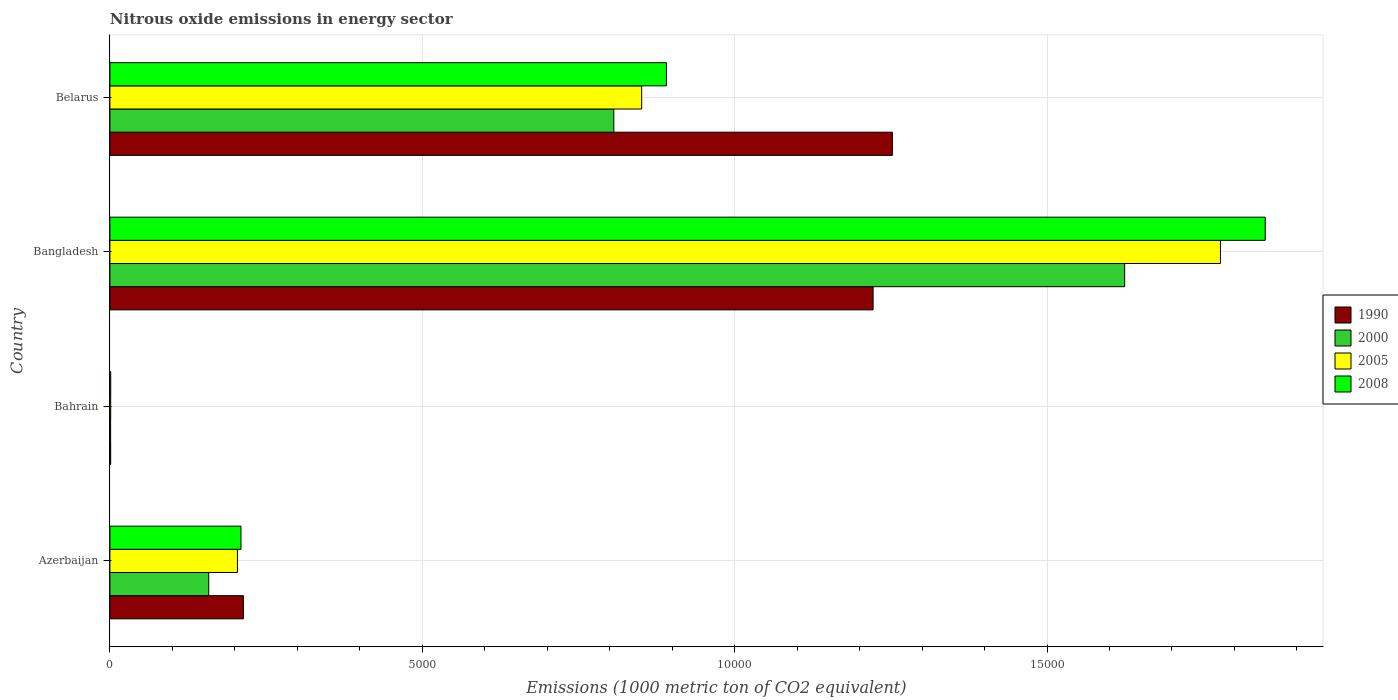How many different coloured bars are there?
Offer a terse response. 4. How many groups of bars are there?
Your response must be concise. 4. Are the number of bars per tick equal to the number of legend labels?
Provide a short and direct response. Yes. How many bars are there on the 2nd tick from the top?
Your response must be concise. 4. How many bars are there on the 2nd tick from the bottom?
Provide a succinct answer. 4. What is the label of the 3rd group of bars from the top?
Your answer should be compact. Bahrain. In how many cases, is the number of bars for a given country not equal to the number of legend labels?
Ensure brevity in your answer.  0. What is the amount of nitrous oxide emitted in 2008 in Belarus?
Offer a very short reply. 8908.4. Across all countries, what is the maximum amount of nitrous oxide emitted in 1990?
Offer a terse response. 1.25e+04. In which country was the amount of nitrous oxide emitted in 2005 minimum?
Your response must be concise. Bahrain. What is the total amount of nitrous oxide emitted in 1990 in the graph?
Offer a terse response. 2.69e+04. What is the difference between the amount of nitrous oxide emitted in 2005 in Bahrain and that in Bangladesh?
Give a very brief answer. -1.78e+04. What is the difference between the amount of nitrous oxide emitted in 2005 in Bahrain and the amount of nitrous oxide emitted in 2000 in Azerbaijan?
Your answer should be compact. -1569. What is the average amount of nitrous oxide emitted in 2000 per country?
Your answer should be compact. 6475.62. What is the difference between the amount of nitrous oxide emitted in 1990 and amount of nitrous oxide emitted in 2005 in Azerbaijan?
Your answer should be very brief. 95.6. In how many countries, is the amount of nitrous oxide emitted in 2000 greater than 4000 1000 metric ton?
Your response must be concise. 2. What is the ratio of the amount of nitrous oxide emitted in 1990 in Azerbaijan to that in Belarus?
Give a very brief answer. 0.17. Is the amount of nitrous oxide emitted in 2005 in Azerbaijan less than that in Bahrain?
Ensure brevity in your answer.  No. What is the difference between the highest and the second highest amount of nitrous oxide emitted in 1990?
Offer a very short reply. 308.3. What is the difference between the highest and the lowest amount of nitrous oxide emitted in 2005?
Your answer should be very brief. 1.78e+04. In how many countries, is the amount of nitrous oxide emitted in 1990 greater than the average amount of nitrous oxide emitted in 1990 taken over all countries?
Give a very brief answer. 2. Is the sum of the amount of nitrous oxide emitted in 2005 in Bahrain and Bangladesh greater than the maximum amount of nitrous oxide emitted in 1990 across all countries?
Provide a succinct answer. Yes. Is it the case that in every country, the sum of the amount of nitrous oxide emitted in 2000 and amount of nitrous oxide emitted in 2008 is greater than the sum of amount of nitrous oxide emitted in 2005 and amount of nitrous oxide emitted in 1990?
Give a very brief answer. No. What does the 3rd bar from the top in Belarus represents?
Your response must be concise. 2000. What does the 2nd bar from the bottom in Belarus represents?
Your response must be concise. 2000. Are all the bars in the graph horizontal?
Make the answer very short. Yes. What is the difference between two consecutive major ticks on the X-axis?
Provide a succinct answer. 5000. Does the graph contain grids?
Make the answer very short. Yes. Where does the legend appear in the graph?
Your answer should be compact. Center right. How many legend labels are there?
Your response must be concise. 4. How are the legend labels stacked?
Make the answer very short. Vertical. What is the title of the graph?
Give a very brief answer. Nitrous oxide emissions in energy sector. What is the label or title of the X-axis?
Offer a terse response. Emissions (1000 metric ton of CO2 equivalent). What is the label or title of the Y-axis?
Make the answer very short. Country. What is the Emissions (1000 metric ton of CO2 equivalent) in 1990 in Azerbaijan?
Ensure brevity in your answer.  2137.1. What is the Emissions (1000 metric ton of CO2 equivalent) of 2000 in Azerbaijan?
Keep it short and to the point. 1582.1. What is the Emissions (1000 metric ton of CO2 equivalent) of 2005 in Azerbaijan?
Offer a terse response. 2041.5. What is the Emissions (1000 metric ton of CO2 equivalent) in 2008 in Azerbaijan?
Provide a short and direct response. 2098. What is the Emissions (1000 metric ton of CO2 equivalent) in 2005 in Bahrain?
Provide a succinct answer. 13.1. What is the Emissions (1000 metric ton of CO2 equivalent) of 2008 in Bahrain?
Offer a very short reply. 13.6. What is the Emissions (1000 metric ton of CO2 equivalent) of 1990 in Bangladesh?
Keep it short and to the point. 1.22e+04. What is the Emissions (1000 metric ton of CO2 equivalent) in 2000 in Bangladesh?
Your answer should be very brief. 1.62e+04. What is the Emissions (1000 metric ton of CO2 equivalent) in 2005 in Bangladesh?
Ensure brevity in your answer.  1.78e+04. What is the Emissions (1000 metric ton of CO2 equivalent) in 2008 in Bangladesh?
Ensure brevity in your answer.  1.85e+04. What is the Emissions (1000 metric ton of CO2 equivalent) in 1990 in Belarus?
Provide a succinct answer. 1.25e+04. What is the Emissions (1000 metric ton of CO2 equivalent) in 2000 in Belarus?
Ensure brevity in your answer.  8066.2. What is the Emissions (1000 metric ton of CO2 equivalent) in 2005 in Belarus?
Give a very brief answer. 8511.9. What is the Emissions (1000 metric ton of CO2 equivalent) in 2008 in Belarus?
Offer a very short reply. 8908.4. Across all countries, what is the maximum Emissions (1000 metric ton of CO2 equivalent) of 1990?
Provide a short and direct response. 1.25e+04. Across all countries, what is the maximum Emissions (1000 metric ton of CO2 equivalent) of 2000?
Provide a short and direct response. 1.62e+04. Across all countries, what is the maximum Emissions (1000 metric ton of CO2 equivalent) of 2005?
Your answer should be compact. 1.78e+04. Across all countries, what is the maximum Emissions (1000 metric ton of CO2 equivalent) of 2008?
Ensure brevity in your answer.  1.85e+04. Across all countries, what is the minimum Emissions (1000 metric ton of CO2 equivalent) in 2000?
Your response must be concise. 11.8. Across all countries, what is the minimum Emissions (1000 metric ton of CO2 equivalent) of 2005?
Provide a short and direct response. 13.1. What is the total Emissions (1000 metric ton of CO2 equivalent) in 1990 in the graph?
Keep it short and to the point. 2.69e+04. What is the total Emissions (1000 metric ton of CO2 equivalent) of 2000 in the graph?
Offer a very short reply. 2.59e+04. What is the total Emissions (1000 metric ton of CO2 equivalent) in 2005 in the graph?
Give a very brief answer. 2.83e+04. What is the total Emissions (1000 metric ton of CO2 equivalent) of 2008 in the graph?
Your answer should be compact. 2.95e+04. What is the difference between the Emissions (1000 metric ton of CO2 equivalent) of 1990 in Azerbaijan and that in Bahrain?
Your response must be concise. 2124.6. What is the difference between the Emissions (1000 metric ton of CO2 equivalent) of 2000 in Azerbaijan and that in Bahrain?
Provide a short and direct response. 1570.3. What is the difference between the Emissions (1000 metric ton of CO2 equivalent) in 2005 in Azerbaijan and that in Bahrain?
Offer a very short reply. 2028.4. What is the difference between the Emissions (1000 metric ton of CO2 equivalent) of 2008 in Azerbaijan and that in Bahrain?
Your response must be concise. 2084.4. What is the difference between the Emissions (1000 metric ton of CO2 equivalent) of 1990 in Azerbaijan and that in Bangladesh?
Keep it short and to the point. -1.01e+04. What is the difference between the Emissions (1000 metric ton of CO2 equivalent) of 2000 in Azerbaijan and that in Bangladesh?
Provide a short and direct response. -1.47e+04. What is the difference between the Emissions (1000 metric ton of CO2 equivalent) in 2005 in Azerbaijan and that in Bangladesh?
Provide a succinct answer. -1.57e+04. What is the difference between the Emissions (1000 metric ton of CO2 equivalent) in 2008 in Azerbaijan and that in Bangladesh?
Your response must be concise. -1.64e+04. What is the difference between the Emissions (1000 metric ton of CO2 equivalent) in 1990 in Azerbaijan and that in Belarus?
Provide a short and direct response. -1.04e+04. What is the difference between the Emissions (1000 metric ton of CO2 equivalent) of 2000 in Azerbaijan and that in Belarus?
Offer a terse response. -6484.1. What is the difference between the Emissions (1000 metric ton of CO2 equivalent) of 2005 in Azerbaijan and that in Belarus?
Ensure brevity in your answer.  -6470.4. What is the difference between the Emissions (1000 metric ton of CO2 equivalent) in 2008 in Azerbaijan and that in Belarus?
Keep it short and to the point. -6810.4. What is the difference between the Emissions (1000 metric ton of CO2 equivalent) of 1990 in Bahrain and that in Bangladesh?
Ensure brevity in your answer.  -1.22e+04. What is the difference between the Emissions (1000 metric ton of CO2 equivalent) of 2000 in Bahrain and that in Bangladesh?
Your answer should be very brief. -1.62e+04. What is the difference between the Emissions (1000 metric ton of CO2 equivalent) in 2005 in Bahrain and that in Bangladesh?
Your response must be concise. -1.78e+04. What is the difference between the Emissions (1000 metric ton of CO2 equivalent) of 2008 in Bahrain and that in Bangladesh?
Offer a terse response. -1.85e+04. What is the difference between the Emissions (1000 metric ton of CO2 equivalent) of 1990 in Bahrain and that in Belarus?
Offer a very short reply. -1.25e+04. What is the difference between the Emissions (1000 metric ton of CO2 equivalent) of 2000 in Bahrain and that in Belarus?
Offer a terse response. -8054.4. What is the difference between the Emissions (1000 metric ton of CO2 equivalent) of 2005 in Bahrain and that in Belarus?
Make the answer very short. -8498.8. What is the difference between the Emissions (1000 metric ton of CO2 equivalent) of 2008 in Bahrain and that in Belarus?
Offer a very short reply. -8894.8. What is the difference between the Emissions (1000 metric ton of CO2 equivalent) in 1990 in Bangladesh and that in Belarus?
Give a very brief answer. -308.3. What is the difference between the Emissions (1000 metric ton of CO2 equivalent) in 2000 in Bangladesh and that in Belarus?
Make the answer very short. 8176.2. What is the difference between the Emissions (1000 metric ton of CO2 equivalent) in 2005 in Bangladesh and that in Belarus?
Offer a very short reply. 9263.9. What is the difference between the Emissions (1000 metric ton of CO2 equivalent) in 2008 in Bangladesh and that in Belarus?
Ensure brevity in your answer.  9584.1. What is the difference between the Emissions (1000 metric ton of CO2 equivalent) of 1990 in Azerbaijan and the Emissions (1000 metric ton of CO2 equivalent) of 2000 in Bahrain?
Make the answer very short. 2125.3. What is the difference between the Emissions (1000 metric ton of CO2 equivalent) in 1990 in Azerbaijan and the Emissions (1000 metric ton of CO2 equivalent) in 2005 in Bahrain?
Provide a succinct answer. 2124. What is the difference between the Emissions (1000 metric ton of CO2 equivalent) in 1990 in Azerbaijan and the Emissions (1000 metric ton of CO2 equivalent) in 2008 in Bahrain?
Your answer should be very brief. 2123.5. What is the difference between the Emissions (1000 metric ton of CO2 equivalent) in 2000 in Azerbaijan and the Emissions (1000 metric ton of CO2 equivalent) in 2005 in Bahrain?
Make the answer very short. 1569. What is the difference between the Emissions (1000 metric ton of CO2 equivalent) in 2000 in Azerbaijan and the Emissions (1000 metric ton of CO2 equivalent) in 2008 in Bahrain?
Ensure brevity in your answer.  1568.5. What is the difference between the Emissions (1000 metric ton of CO2 equivalent) in 2005 in Azerbaijan and the Emissions (1000 metric ton of CO2 equivalent) in 2008 in Bahrain?
Make the answer very short. 2027.9. What is the difference between the Emissions (1000 metric ton of CO2 equivalent) of 1990 in Azerbaijan and the Emissions (1000 metric ton of CO2 equivalent) of 2000 in Bangladesh?
Your answer should be very brief. -1.41e+04. What is the difference between the Emissions (1000 metric ton of CO2 equivalent) in 1990 in Azerbaijan and the Emissions (1000 metric ton of CO2 equivalent) in 2005 in Bangladesh?
Ensure brevity in your answer.  -1.56e+04. What is the difference between the Emissions (1000 metric ton of CO2 equivalent) in 1990 in Azerbaijan and the Emissions (1000 metric ton of CO2 equivalent) in 2008 in Bangladesh?
Provide a succinct answer. -1.64e+04. What is the difference between the Emissions (1000 metric ton of CO2 equivalent) in 2000 in Azerbaijan and the Emissions (1000 metric ton of CO2 equivalent) in 2005 in Bangladesh?
Your response must be concise. -1.62e+04. What is the difference between the Emissions (1000 metric ton of CO2 equivalent) in 2000 in Azerbaijan and the Emissions (1000 metric ton of CO2 equivalent) in 2008 in Bangladesh?
Provide a short and direct response. -1.69e+04. What is the difference between the Emissions (1000 metric ton of CO2 equivalent) of 2005 in Azerbaijan and the Emissions (1000 metric ton of CO2 equivalent) of 2008 in Bangladesh?
Your answer should be compact. -1.65e+04. What is the difference between the Emissions (1000 metric ton of CO2 equivalent) of 1990 in Azerbaijan and the Emissions (1000 metric ton of CO2 equivalent) of 2000 in Belarus?
Provide a short and direct response. -5929.1. What is the difference between the Emissions (1000 metric ton of CO2 equivalent) of 1990 in Azerbaijan and the Emissions (1000 metric ton of CO2 equivalent) of 2005 in Belarus?
Provide a succinct answer. -6374.8. What is the difference between the Emissions (1000 metric ton of CO2 equivalent) of 1990 in Azerbaijan and the Emissions (1000 metric ton of CO2 equivalent) of 2008 in Belarus?
Offer a terse response. -6771.3. What is the difference between the Emissions (1000 metric ton of CO2 equivalent) in 2000 in Azerbaijan and the Emissions (1000 metric ton of CO2 equivalent) in 2005 in Belarus?
Provide a succinct answer. -6929.8. What is the difference between the Emissions (1000 metric ton of CO2 equivalent) in 2000 in Azerbaijan and the Emissions (1000 metric ton of CO2 equivalent) in 2008 in Belarus?
Your answer should be compact. -7326.3. What is the difference between the Emissions (1000 metric ton of CO2 equivalent) in 2005 in Azerbaijan and the Emissions (1000 metric ton of CO2 equivalent) in 2008 in Belarus?
Offer a very short reply. -6866.9. What is the difference between the Emissions (1000 metric ton of CO2 equivalent) in 1990 in Bahrain and the Emissions (1000 metric ton of CO2 equivalent) in 2000 in Bangladesh?
Give a very brief answer. -1.62e+04. What is the difference between the Emissions (1000 metric ton of CO2 equivalent) of 1990 in Bahrain and the Emissions (1000 metric ton of CO2 equivalent) of 2005 in Bangladesh?
Make the answer very short. -1.78e+04. What is the difference between the Emissions (1000 metric ton of CO2 equivalent) of 1990 in Bahrain and the Emissions (1000 metric ton of CO2 equivalent) of 2008 in Bangladesh?
Keep it short and to the point. -1.85e+04. What is the difference between the Emissions (1000 metric ton of CO2 equivalent) in 2000 in Bahrain and the Emissions (1000 metric ton of CO2 equivalent) in 2005 in Bangladesh?
Offer a very short reply. -1.78e+04. What is the difference between the Emissions (1000 metric ton of CO2 equivalent) of 2000 in Bahrain and the Emissions (1000 metric ton of CO2 equivalent) of 2008 in Bangladesh?
Your answer should be very brief. -1.85e+04. What is the difference between the Emissions (1000 metric ton of CO2 equivalent) in 2005 in Bahrain and the Emissions (1000 metric ton of CO2 equivalent) in 2008 in Bangladesh?
Your answer should be very brief. -1.85e+04. What is the difference between the Emissions (1000 metric ton of CO2 equivalent) in 1990 in Bahrain and the Emissions (1000 metric ton of CO2 equivalent) in 2000 in Belarus?
Keep it short and to the point. -8053.7. What is the difference between the Emissions (1000 metric ton of CO2 equivalent) in 1990 in Bahrain and the Emissions (1000 metric ton of CO2 equivalent) in 2005 in Belarus?
Give a very brief answer. -8499.4. What is the difference between the Emissions (1000 metric ton of CO2 equivalent) in 1990 in Bahrain and the Emissions (1000 metric ton of CO2 equivalent) in 2008 in Belarus?
Provide a short and direct response. -8895.9. What is the difference between the Emissions (1000 metric ton of CO2 equivalent) in 2000 in Bahrain and the Emissions (1000 metric ton of CO2 equivalent) in 2005 in Belarus?
Your answer should be compact. -8500.1. What is the difference between the Emissions (1000 metric ton of CO2 equivalent) in 2000 in Bahrain and the Emissions (1000 metric ton of CO2 equivalent) in 2008 in Belarus?
Your answer should be compact. -8896.6. What is the difference between the Emissions (1000 metric ton of CO2 equivalent) of 2005 in Bahrain and the Emissions (1000 metric ton of CO2 equivalent) of 2008 in Belarus?
Offer a very short reply. -8895.3. What is the difference between the Emissions (1000 metric ton of CO2 equivalent) of 1990 in Bangladesh and the Emissions (1000 metric ton of CO2 equivalent) of 2000 in Belarus?
Give a very brief answer. 4150.1. What is the difference between the Emissions (1000 metric ton of CO2 equivalent) of 1990 in Bangladesh and the Emissions (1000 metric ton of CO2 equivalent) of 2005 in Belarus?
Your answer should be very brief. 3704.4. What is the difference between the Emissions (1000 metric ton of CO2 equivalent) of 1990 in Bangladesh and the Emissions (1000 metric ton of CO2 equivalent) of 2008 in Belarus?
Provide a succinct answer. 3307.9. What is the difference between the Emissions (1000 metric ton of CO2 equivalent) of 2000 in Bangladesh and the Emissions (1000 metric ton of CO2 equivalent) of 2005 in Belarus?
Provide a short and direct response. 7730.5. What is the difference between the Emissions (1000 metric ton of CO2 equivalent) in 2000 in Bangladesh and the Emissions (1000 metric ton of CO2 equivalent) in 2008 in Belarus?
Make the answer very short. 7334. What is the difference between the Emissions (1000 metric ton of CO2 equivalent) in 2005 in Bangladesh and the Emissions (1000 metric ton of CO2 equivalent) in 2008 in Belarus?
Offer a terse response. 8867.4. What is the average Emissions (1000 metric ton of CO2 equivalent) of 1990 per country?
Your answer should be very brief. 6722.62. What is the average Emissions (1000 metric ton of CO2 equivalent) in 2000 per country?
Provide a short and direct response. 6475.62. What is the average Emissions (1000 metric ton of CO2 equivalent) of 2005 per country?
Keep it short and to the point. 7085.57. What is the average Emissions (1000 metric ton of CO2 equivalent) of 2008 per country?
Provide a short and direct response. 7378.12. What is the difference between the Emissions (1000 metric ton of CO2 equivalent) of 1990 and Emissions (1000 metric ton of CO2 equivalent) of 2000 in Azerbaijan?
Make the answer very short. 555. What is the difference between the Emissions (1000 metric ton of CO2 equivalent) in 1990 and Emissions (1000 metric ton of CO2 equivalent) in 2005 in Azerbaijan?
Provide a short and direct response. 95.6. What is the difference between the Emissions (1000 metric ton of CO2 equivalent) in 1990 and Emissions (1000 metric ton of CO2 equivalent) in 2008 in Azerbaijan?
Your answer should be very brief. 39.1. What is the difference between the Emissions (1000 metric ton of CO2 equivalent) of 2000 and Emissions (1000 metric ton of CO2 equivalent) of 2005 in Azerbaijan?
Ensure brevity in your answer.  -459.4. What is the difference between the Emissions (1000 metric ton of CO2 equivalent) of 2000 and Emissions (1000 metric ton of CO2 equivalent) of 2008 in Azerbaijan?
Provide a succinct answer. -515.9. What is the difference between the Emissions (1000 metric ton of CO2 equivalent) of 2005 and Emissions (1000 metric ton of CO2 equivalent) of 2008 in Azerbaijan?
Your answer should be very brief. -56.5. What is the difference between the Emissions (1000 metric ton of CO2 equivalent) of 1990 and Emissions (1000 metric ton of CO2 equivalent) of 2005 in Bahrain?
Provide a short and direct response. -0.6. What is the difference between the Emissions (1000 metric ton of CO2 equivalent) in 2000 and Emissions (1000 metric ton of CO2 equivalent) in 2008 in Bahrain?
Make the answer very short. -1.8. What is the difference between the Emissions (1000 metric ton of CO2 equivalent) of 1990 and Emissions (1000 metric ton of CO2 equivalent) of 2000 in Bangladesh?
Your answer should be very brief. -4026.1. What is the difference between the Emissions (1000 metric ton of CO2 equivalent) in 1990 and Emissions (1000 metric ton of CO2 equivalent) in 2005 in Bangladesh?
Ensure brevity in your answer.  -5559.5. What is the difference between the Emissions (1000 metric ton of CO2 equivalent) of 1990 and Emissions (1000 metric ton of CO2 equivalent) of 2008 in Bangladesh?
Ensure brevity in your answer.  -6276.2. What is the difference between the Emissions (1000 metric ton of CO2 equivalent) of 2000 and Emissions (1000 metric ton of CO2 equivalent) of 2005 in Bangladesh?
Your response must be concise. -1533.4. What is the difference between the Emissions (1000 metric ton of CO2 equivalent) of 2000 and Emissions (1000 metric ton of CO2 equivalent) of 2008 in Bangladesh?
Provide a short and direct response. -2250.1. What is the difference between the Emissions (1000 metric ton of CO2 equivalent) of 2005 and Emissions (1000 metric ton of CO2 equivalent) of 2008 in Bangladesh?
Your answer should be very brief. -716.7. What is the difference between the Emissions (1000 metric ton of CO2 equivalent) in 1990 and Emissions (1000 metric ton of CO2 equivalent) in 2000 in Belarus?
Your answer should be compact. 4458.4. What is the difference between the Emissions (1000 metric ton of CO2 equivalent) in 1990 and Emissions (1000 metric ton of CO2 equivalent) in 2005 in Belarus?
Ensure brevity in your answer.  4012.7. What is the difference between the Emissions (1000 metric ton of CO2 equivalent) of 1990 and Emissions (1000 metric ton of CO2 equivalent) of 2008 in Belarus?
Offer a terse response. 3616.2. What is the difference between the Emissions (1000 metric ton of CO2 equivalent) of 2000 and Emissions (1000 metric ton of CO2 equivalent) of 2005 in Belarus?
Your response must be concise. -445.7. What is the difference between the Emissions (1000 metric ton of CO2 equivalent) of 2000 and Emissions (1000 metric ton of CO2 equivalent) of 2008 in Belarus?
Provide a succinct answer. -842.2. What is the difference between the Emissions (1000 metric ton of CO2 equivalent) of 2005 and Emissions (1000 metric ton of CO2 equivalent) of 2008 in Belarus?
Make the answer very short. -396.5. What is the ratio of the Emissions (1000 metric ton of CO2 equivalent) of 1990 in Azerbaijan to that in Bahrain?
Offer a very short reply. 170.97. What is the ratio of the Emissions (1000 metric ton of CO2 equivalent) of 2000 in Azerbaijan to that in Bahrain?
Your answer should be compact. 134.08. What is the ratio of the Emissions (1000 metric ton of CO2 equivalent) of 2005 in Azerbaijan to that in Bahrain?
Make the answer very short. 155.84. What is the ratio of the Emissions (1000 metric ton of CO2 equivalent) of 2008 in Azerbaijan to that in Bahrain?
Your response must be concise. 154.26. What is the ratio of the Emissions (1000 metric ton of CO2 equivalent) of 1990 in Azerbaijan to that in Bangladesh?
Provide a short and direct response. 0.17. What is the ratio of the Emissions (1000 metric ton of CO2 equivalent) of 2000 in Azerbaijan to that in Bangladesh?
Your answer should be very brief. 0.1. What is the ratio of the Emissions (1000 metric ton of CO2 equivalent) in 2005 in Azerbaijan to that in Bangladesh?
Ensure brevity in your answer.  0.11. What is the ratio of the Emissions (1000 metric ton of CO2 equivalent) of 2008 in Azerbaijan to that in Bangladesh?
Give a very brief answer. 0.11. What is the ratio of the Emissions (1000 metric ton of CO2 equivalent) in 1990 in Azerbaijan to that in Belarus?
Make the answer very short. 0.17. What is the ratio of the Emissions (1000 metric ton of CO2 equivalent) of 2000 in Azerbaijan to that in Belarus?
Make the answer very short. 0.2. What is the ratio of the Emissions (1000 metric ton of CO2 equivalent) in 2005 in Azerbaijan to that in Belarus?
Offer a terse response. 0.24. What is the ratio of the Emissions (1000 metric ton of CO2 equivalent) of 2008 in Azerbaijan to that in Belarus?
Make the answer very short. 0.24. What is the ratio of the Emissions (1000 metric ton of CO2 equivalent) in 1990 in Bahrain to that in Bangladesh?
Keep it short and to the point. 0. What is the ratio of the Emissions (1000 metric ton of CO2 equivalent) in 2000 in Bahrain to that in Bangladesh?
Your answer should be very brief. 0. What is the ratio of the Emissions (1000 metric ton of CO2 equivalent) in 2005 in Bahrain to that in Bangladesh?
Ensure brevity in your answer.  0. What is the ratio of the Emissions (1000 metric ton of CO2 equivalent) of 2008 in Bahrain to that in Bangladesh?
Your response must be concise. 0. What is the ratio of the Emissions (1000 metric ton of CO2 equivalent) of 1990 in Bahrain to that in Belarus?
Offer a terse response. 0. What is the ratio of the Emissions (1000 metric ton of CO2 equivalent) of 2000 in Bahrain to that in Belarus?
Your answer should be compact. 0. What is the ratio of the Emissions (1000 metric ton of CO2 equivalent) in 2005 in Bahrain to that in Belarus?
Provide a short and direct response. 0. What is the ratio of the Emissions (1000 metric ton of CO2 equivalent) of 2008 in Bahrain to that in Belarus?
Your response must be concise. 0. What is the ratio of the Emissions (1000 metric ton of CO2 equivalent) in 1990 in Bangladesh to that in Belarus?
Provide a short and direct response. 0.98. What is the ratio of the Emissions (1000 metric ton of CO2 equivalent) in 2000 in Bangladesh to that in Belarus?
Make the answer very short. 2.01. What is the ratio of the Emissions (1000 metric ton of CO2 equivalent) of 2005 in Bangladesh to that in Belarus?
Your response must be concise. 2.09. What is the ratio of the Emissions (1000 metric ton of CO2 equivalent) in 2008 in Bangladesh to that in Belarus?
Your answer should be compact. 2.08. What is the difference between the highest and the second highest Emissions (1000 metric ton of CO2 equivalent) of 1990?
Provide a short and direct response. 308.3. What is the difference between the highest and the second highest Emissions (1000 metric ton of CO2 equivalent) in 2000?
Give a very brief answer. 8176.2. What is the difference between the highest and the second highest Emissions (1000 metric ton of CO2 equivalent) in 2005?
Your answer should be compact. 9263.9. What is the difference between the highest and the second highest Emissions (1000 metric ton of CO2 equivalent) of 2008?
Offer a very short reply. 9584.1. What is the difference between the highest and the lowest Emissions (1000 metric ton of CO2 equivalent) in 1990?
Offer a very short reply. 1.25e+04. What is the difference between the highest and the lowest Emissions (1000 metric ton of CO2 equivalent) in 2000?
Your response must be concise. 1.62e+04. What is the difference between the highest and the lowest Emissions (1000 metric ton of CO2 equivalent) of 2005?
Offer a terse response. 1.78e+04. What is the difference between the highest and the lowest Emissions (1000 metric ton of CO2 equivalent) of 2008?
Your answer should be very brief. 1.85e+04. 